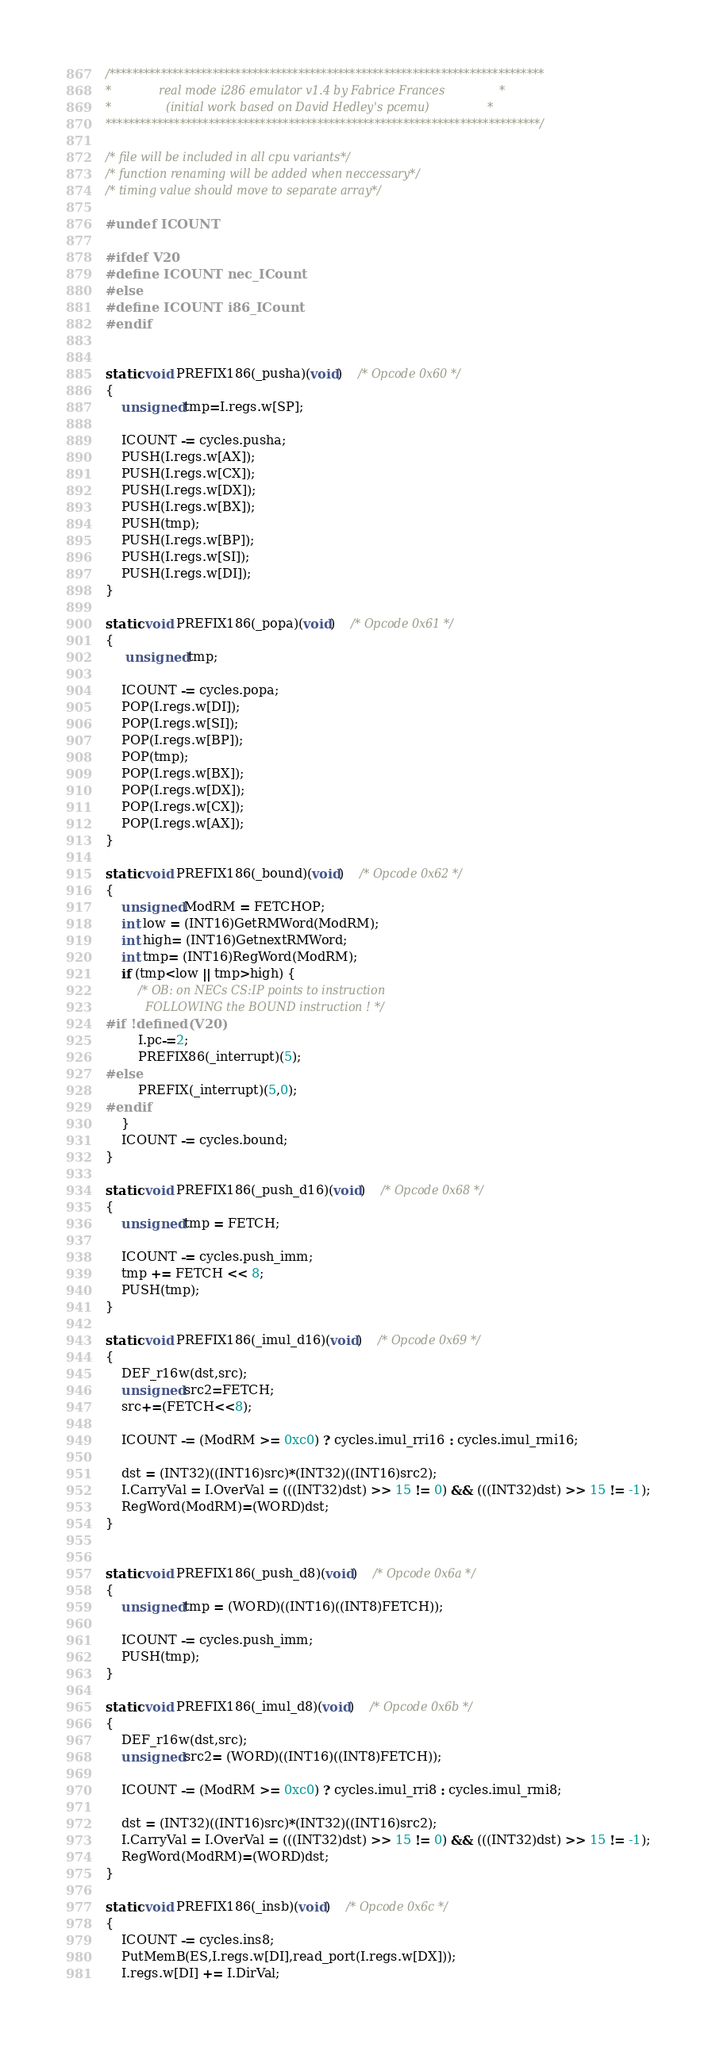<code> <loc_0><loc_0><loc_500><loc_500><_C_>/****************************************************************************
*			  real mode i286 emulator v1.4 by Fabrice Frances				*
*				(initial work based on David Hedley's pcemu)                *
****************************************************************************/

/* file will be included in all cpu variants*/
/* function renaming will be added when neccessary*/
/* timing value should move to separate array*/

#undef ICOUNT

#ifdef V20
#define ICOUNT nec_ICount
#else
#define ICOUNT i86_ICount
#endif


static void PREFIX186(_pusha)(void)    /* Opcode 0x60 */
{
	unsigned tmp=I.regs.w[SP];

	ICOUNT -= cycles.pusha;
	PUSH(I.regs.w[AX]);
	PUSH(I.regs.w[CX]);
	PUSH(I.regs.w[DX]);
	PUSH(I.regs.w[BX]);
    PUSH(tmp);
	PUSH(I.regs.w[BP]);
	PUSH(I.regs.w[SI]);
	PUSH(I.regs.w[DI]);
}

static void PREFIX186(_popa)(void)    /* Opcode 0x61 */
{
	 unsigned tmp;

	ICOUNT -= cycles.popa;
	POP(I.regs.w[DI]);
	POP(I.regs.w[SI]);
	POP(I.regs.w[BP]);
	POP(tmp);
	POP(I.regs.w[BX]);
	POP(I.regs.w[DX]);
	POP(I.regs.w[CX]);
	POP(I.regs.w[AX]);
}

static void PREFIX186(_bound)(void)    /* Opcode 0x62 */
{
	unsigned ModRM = FETCHOP;
	int low = (INT16)GetRMWord(ModRM);
    int high= (INT16)GetnextRMWord;
	int tmp= (INT16)RegWord(ModRM);
	if (tmp<low || tmp>high) {
		/* OB: on NECs CS:IP points to instruction
		   FOLLOWING the BOUND instruction ! */
#if !defined(V20)
		I.pc-=2;
		PREFIX86(_interrupt)(5);
#else
		PREFIX(_interrupt)(5,0);
#endif
	}
	ICOUNT -= cycles.bound;
}

static void PREFIX186(_push_d16)(void)    /* Opcode 0x68 */
{
	unsigned tmp = FETCH;

	ICOUNT -= cycles.push_imm;
	tmp += FETCH << 8;
	PUSH(tmp);
}

static void PREFIX186(_imul_d16)(void)    /* Opcode 0x69 */
{
	DEF_r16w(dst,src);
	unsigned src2=FETCH;
	src+=(FETCH<<8);

	ICOUNT -= (ModRM >= 0xc0) ? cycles.imul_rri16 : cycles.imul_rmi16;

	dst = (INT32)((INT16)src)*(INT32)((INT16)src2);
	I.CarryVal = I.OverVal = (((INT32)dst) >> 15 != 0) && (((INT32)dst) >> 15 != -1);
	RegWord(ModRM)=(WORD)dst;
}


static void PREFIX186(_push_d8)(void)    /* Opcode 0x6a */
{
	unsigned tmp = (WORD)((INT16)((INT8)FETCH));

	ICOUNT -= cycles.push_imm;
	PUSH(tmp);
}

static void PREFIX186(_imul_d8)(void)    /* Opcode 0x6b */
{
	DEF_r16w(dst,src);
	unsigned src2= (WORD)((INT16)((INT8)FETCH));

	ICOUNT -= (ModRM >= 0xc0) ? cycles.imul_rri8 : cycles.imul_rmi8;

	dst = (INT32)((INT16)src)*(INT32)((INT16)src2);
	I.CarryVal = I.OverVal = (((INT32)dst) >> 15 != 0) && (((INT32)dst) >> 15 != -1);
	RegWord(ModRM)=(WORD)dst;
}

static void PREFIX186(_insb)(void)    /* Opcode 0x6c */
{
	ICOUNT -= cycles.ins8;
	PutMemB(ES,I.regs.w[DI],read_port(I.regs.w[DX]));
	I.regs.w[DI] += I.DirVal;</code> 